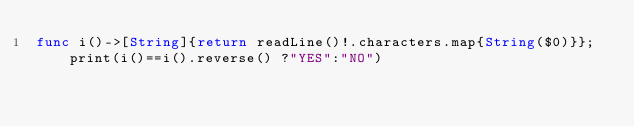<code> <loc_0><loc_0><loc_500><loc_500><_Swift_>func i()->[String]{return readLine()!.characters.map{String($0)}};print(i()==i().reverse() ?"YES":"NO")</code> 